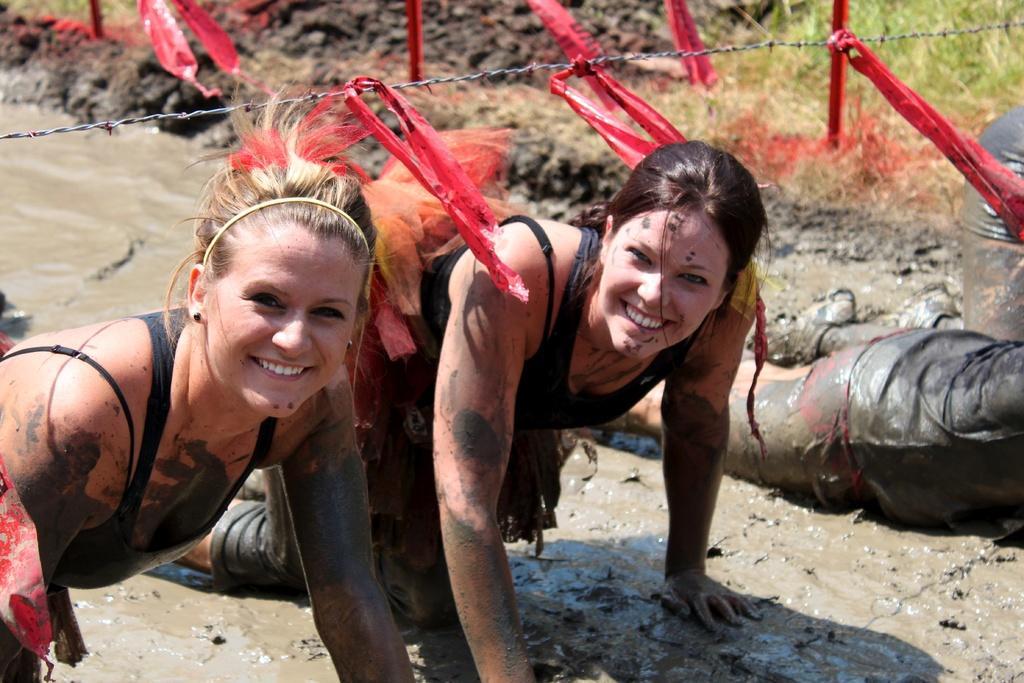Describe this image in one or two sentences. In this image there are four persons playing in mud at the top there is a wire. 